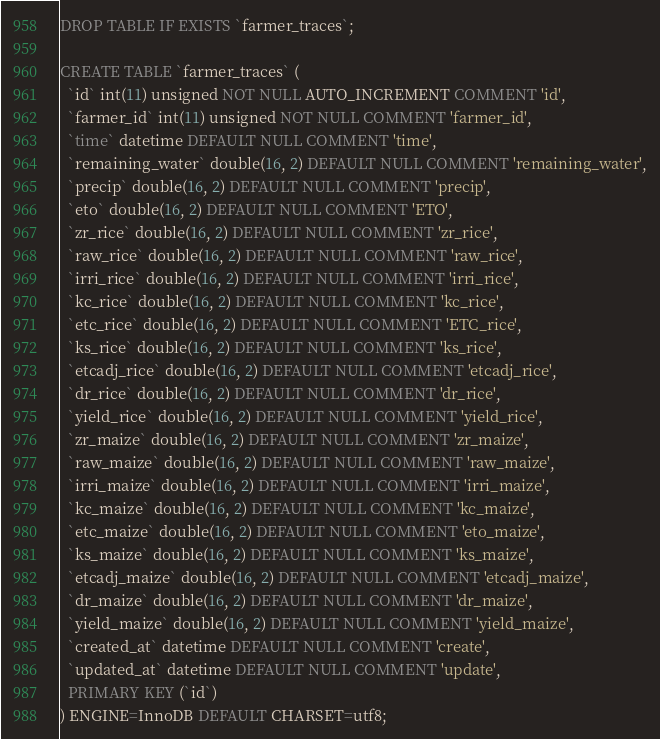<code> <loc_0><loc_0><loc_500><loc_500><_SQL_>DROP TABLE IF EXISTS `farmer_traces`;

CREATE TABLE `farmer_traces` (
  `id` int(11) unsigned NOT NULL AUTO_INCREMENT COMMENT 'id',
  `farmer_id` int(11) unsigned NOT NULL COMMENT 'farmer_id',
  `time` datetime DEFAULT NULL COMMENT 'time',
  `remaining_water` double(16, 2) DEFAULT NULL COMMENT 'remaining_water',
  `precip` double(16, 2) DEFAULT NULL COMMENT 'precip',
  `eto` double(16, 2) DEFAULT NULL COMMENT 'ETO',
  `zr_rice` double(16, 2) DEFAULT NULL COMMENT 'zr_rice',
  `raw_rice` double(16, 2) DEFAULT NULL COMMENT 'raw_rice',
  `irri_rice` double(16, 2) DEFAULT NULL COMMENT 'irri_rice',
  `kc_rice` double(16, 2) DEFAULT NULL COMMENT 'kc_rice',
  `etc_rice` double(16, 2) DEFAULT NULL COMMENT 'ETC_rice',
  `ks_rice` double(16, 2) DEFAULT NULL COMMENT 'ks_rice',
  `etcadj_rice` double(16, 2) DEFAULT NULL COMMENT 'etcadj_rice',
  `dr_rice` double(16, 2) DEFAULT NULL COMMENT 'dr_rice',
  `yield_rice` double(16, 2) DEFAULT NULL COMMENT 'yield_rice',
  `zr_maize` double(16, 2) DEFAULT NULL COMMENT 'zr_maize',
  `raw_maize` double(16, 2) DEFAULT NULL COMMENT 'raw_maize',
  `irri_maize` double(16, 2) DEFAULT NULL COMMENT 'irri_maize',
  `kc_maize` double(16, 2) DEFAULT NULL COMMENT 'kc_maize',
  `etc_maize` double(16, 2) DEFAULT NULL COMMENT 'eto_maize',
  `ks_maize` double(16, 2) DEFAULT NULL COMMENT 'ks_maize',
  `etcadj_maize` double(16, 2) DEFAULT NULL COMMENT 'etcadj_maize',
  `dr_maize` double(16, 2) DEFAULT NULL COMMENT 'dr_maize',
  `yield_maize` double(16, 2) DEFAULT NULL COMMENT 'yield_maize',
  `created_at` datetime DEFAULT NULL COMMENT 'create',
  `updated_at` datetime DEFAULT NULL COMMENT 'update',
  PRIMARY KEY (`id`)
) ENGINE=InnoDB DEFAULT CHARSET=utf8;</code> 